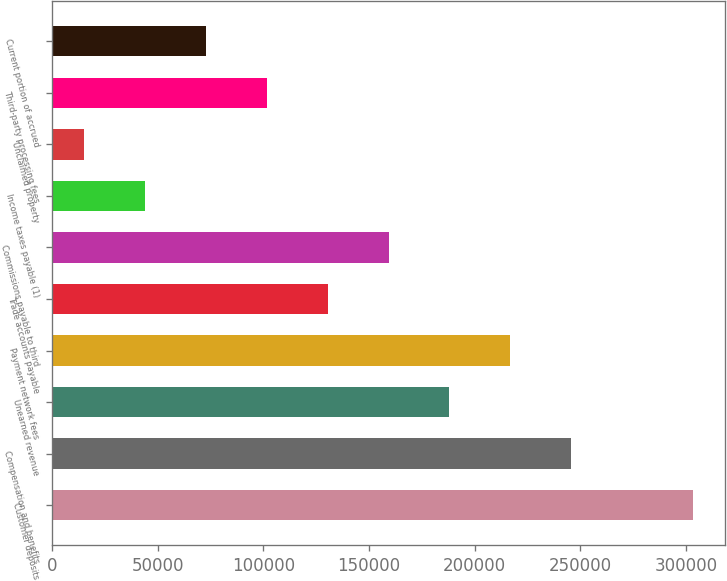Convert chart to OTSL. <chart><loc_0><loc_0><loc_500><loc_500><bar_chart><fcel>Customer deposits<fcel>Compensation and benefits<fcel>Unearned revenue<fcel>Payment network fees<fcel>Trade accounts payable<fcel>Commissions payable to third<fcel>Income taxes payable (1)<fcel>Unclaimed property<fcel>Third-party processing fees<fcel>Current portion of accrued<nl><fcel>303353<fcel>245714<fcel>188074<fcel>216894<fcel>130435<fcel>159254<fcel>43975.7<fcel>15156<fcel>101615<fcel>72795.4<nl></chart> 